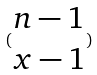<formula> <loc_0><loc_0><loc_500><loc_500>( \begin{matrix} n - 1 \\ x - 1 \end{matrix} )</formula> 